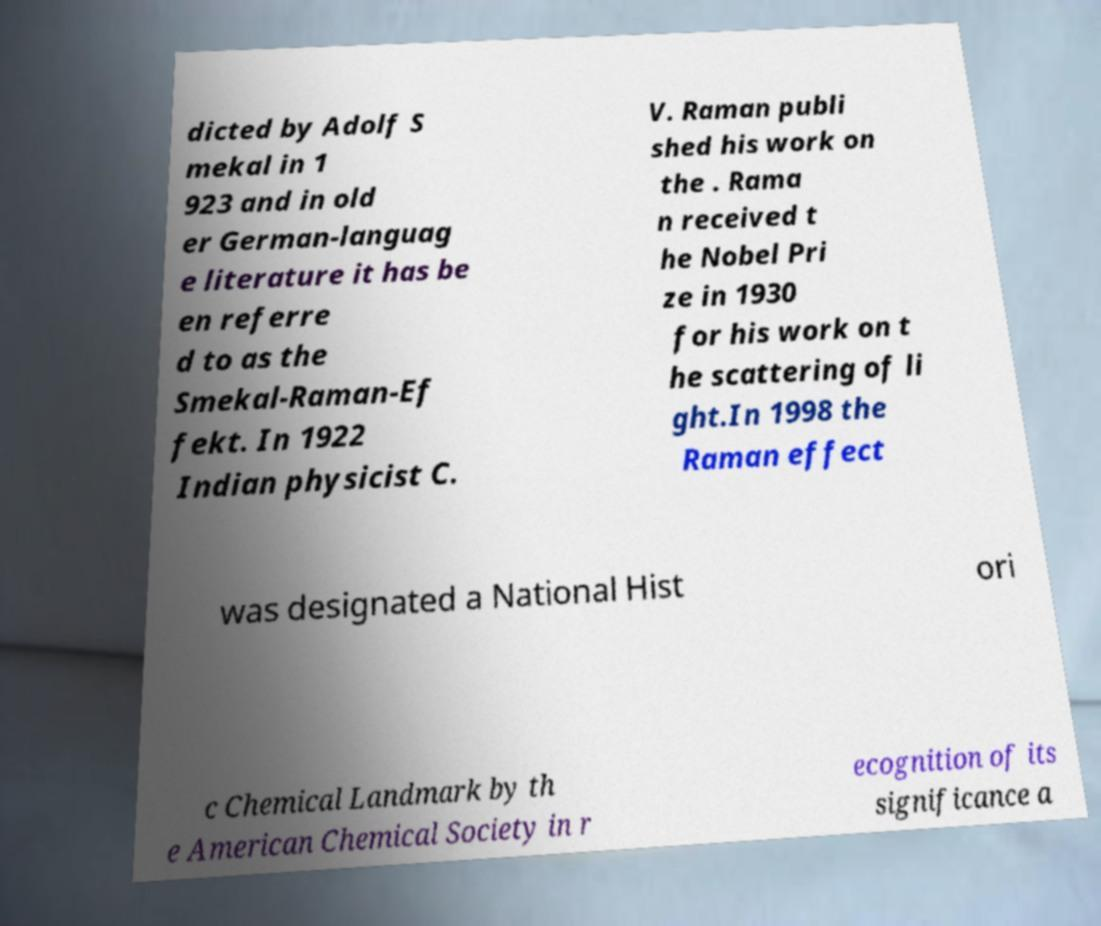Please identify and transcribe the text found in this image. dicted by Adolf S mekal in 1 923 and in old er German-languag e literature it has be en referre d to as the Smekal-Raman-Ef fekt. In 1922 Indian physicist C. V. Raman publi shed his work on the . Rama n received t he Nobel Pri ze in 1930 for his work on t he scattering of li ght.In 1998 the Raman effect was designated a National Hist ori c Chemical Landmark by th e American Chemical Society in r ecognition of its significance a 